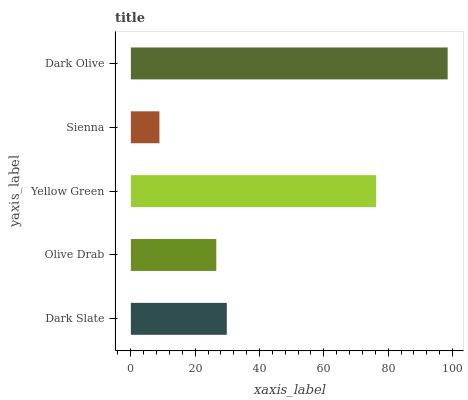Is Sienna the minimum?
Answer yes or no. Yes. Is Dark Olive the maximum?
Answer yes or no. Yes. Is Olive Drab the minimum?
Answer yes or no. No. Is Olive Drab the maximum?
Answer yes or no. No. Is Dark Slate greater than Olive Drab?
Answer yes or no. Yes. Is Olive Drab less than Dark Slate?
Answer yes or no. Yes. Is Olive Drab greater than Dark Slate?
Answer yes or no. No. Is Dark Slate less than Olive Drab?
Answer yes or no. No. Is Dark Slate the high median?
Answer yes or no. Yes. Is Dark Slate the low median?
Answer yes or no. Yes. Is Dark Olive the high median?
Answer yes or no. No. Is Dark Olive the low median?
Answer yes or no. No. 